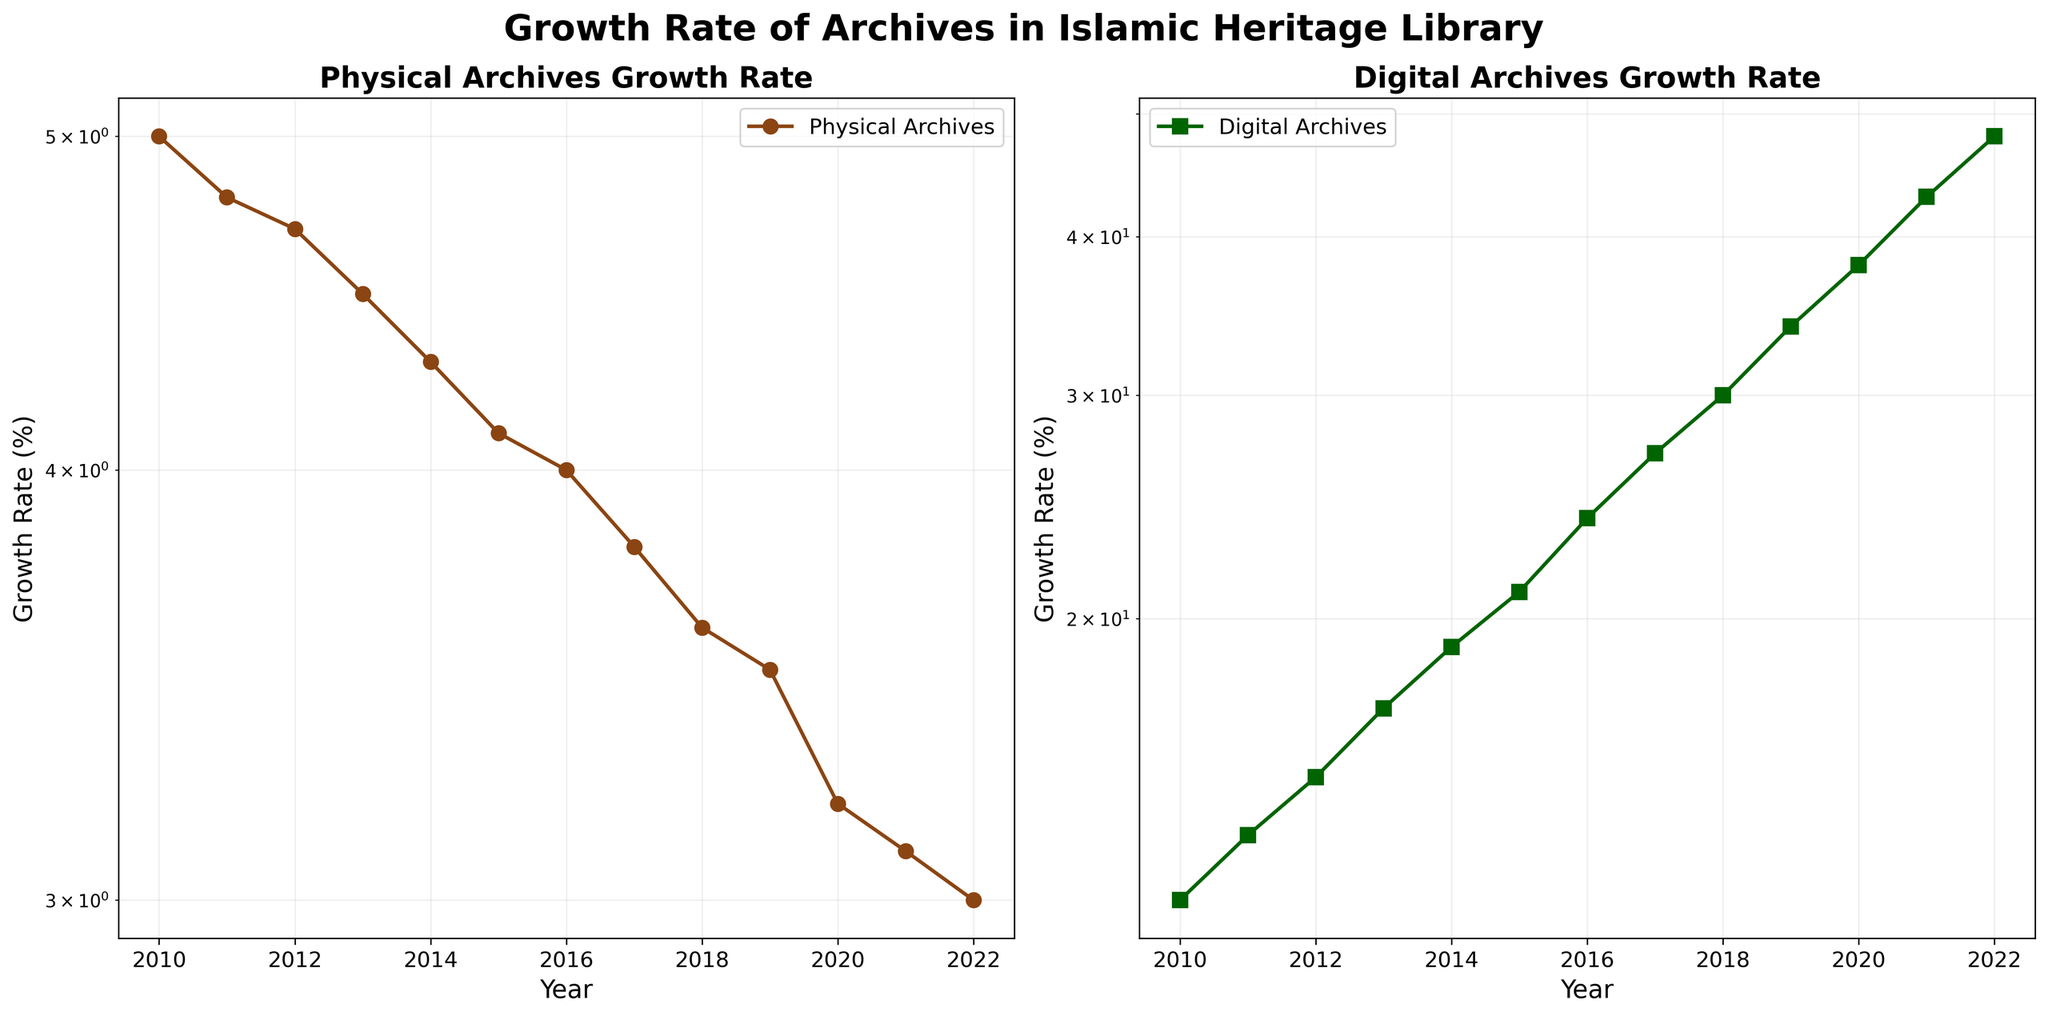What are the colors used for the lines representing Physical Archives and Digital Archives? The figure uses two different colors to distinguish between the two datasets. The Physical Archives line is marked in brown, while the Digital Archives line appears in green.
Answer: Brown for Physical Archives and Green for Digital Archives What is the title of the figure? The title is displayed at the top center of the figure, providing a summary of the contents covered within the subplots.
Answer: Growth Rate of Archives in Islamic Heritage Library How many data points are shown for each archive type? By counting the data markers on the lines for both Physical and Digital Archives in the figure, we can determine the number of data points presented.
Answer: 13 for each archive type What are the years covered in this figure? The years are plotted along the X-axis, and they range from the first to the last value presented.
Answer: 2010 to 2022 How does the growth rate of Digital Archives in 2015 compare to that of Physical Archives? By referring to the data points on the figure, we can see the growth rate for both archive types in 2015. The Digital Archives have a higher growth rate than the Physical Archives in that year.
Answer: Digital Archives have a higher growth rate What was the approximate growth rate of Physical Archives in 2018? The Y-axis values and the corresponding data point for the Physical Archives in the year 2018 can be used to find this value.
Answer: Approximately 3.6% How did the growth rate of Digital Archives change from 2019 to 2020? Observing the data points for the Digital Archives for the years 2019 and 2020, we can see that the growth rate increased.
Answer: Increased What year did the growth rate of Digital Archives reach 30%? By finding the year on the X-axis that corresponds to the 30% growth rate on the Digital Archives line, we can identify the year.
Answer: 2018 Compare the average growth rates of Physical Archives and Digital Archives over the entire period. To find the average, sum the growth rates of each archive type over all the years and divide by the number of years.
Answer: Average for Physical: 3.985%, Average for Digital: 25.19% Which archive type has shown a consistent decrease in its growth rate over the years? By examining the trend lines for both archive types, it is clear that one has a downward trend while the other might have an upward trend.
Answer: Physical Archives 